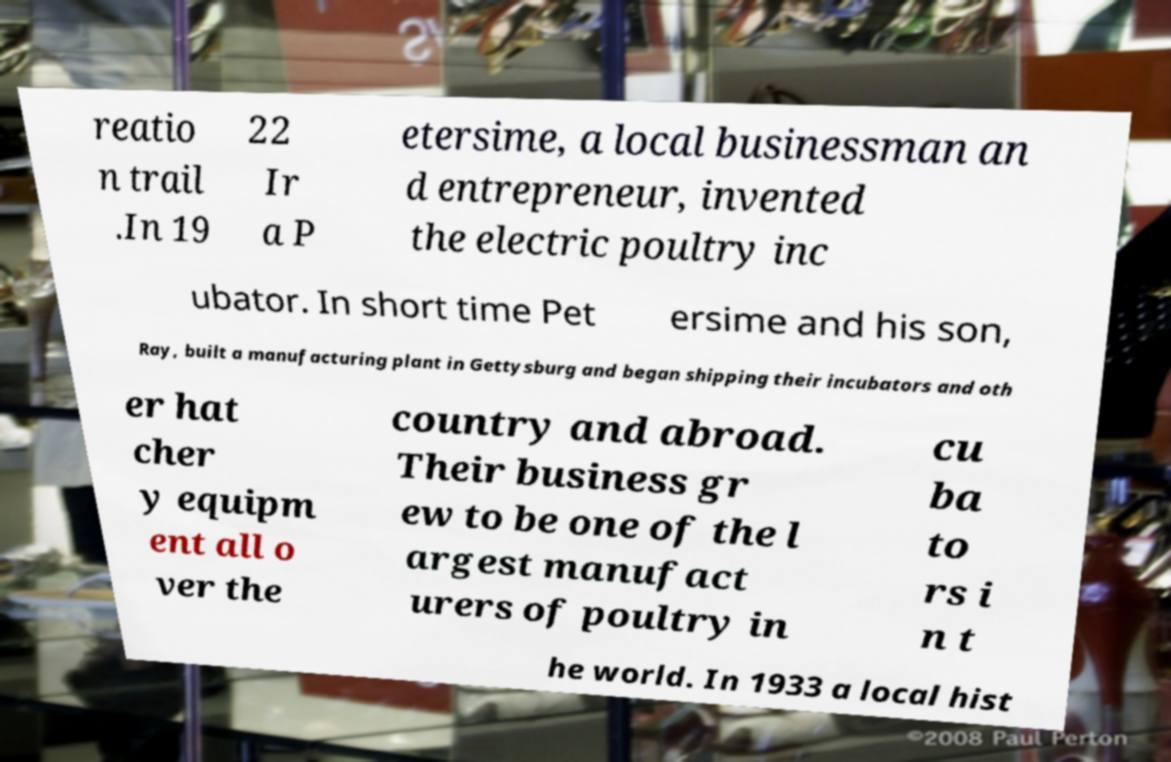For documentation purposes, I need the text within this image transcribed. Could you provide that? reatio n trail .In 19 22 Ir a P etersime, a local businessman an d entrepreneur, invented the electric poultry inc ubator. In short time Pet ersime and his son, Ray, built a manufacturing plant in Gettysburg and began shipping their incubators and oth er hat cher y equipm ent all o ver the country and abroad. Their business gr ew to be one of the l argest manufact urers of poultry in cu ba to rs i n t he world. In 1933 a local hist 